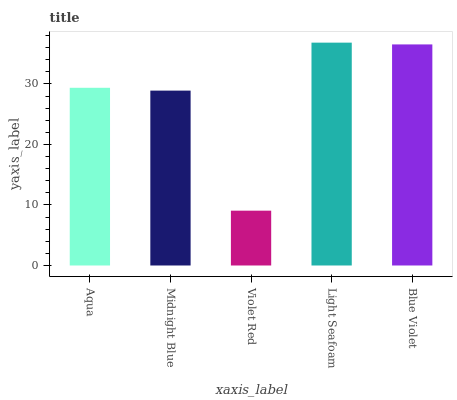Is Violet Red the minimum?
Answer yes or no. Yes. Is Light Seafoam the maximum?
Answer yes or no. Yes. Is Midnight Blue the minimum?
Answer yes or no. No. Is Midnight Blue the maximum?
Answer yes or no. No. Is Aqua greater than Midnight Blue?
Answer yes or no. Yes. Is Midnight Blue less than Aqua?
Answer yes or no. Yes. Is Midnight Blue greater than Aqua?
Answer yes or no. No. Is Aqua less than Midnight Blue?
Answer yes or no. No. Is Aqua the high median?
Answer yes or no. Yes. Is Aqua the low median?
Answer yes or no. Yes. Is Violet Red the high median?
Answer yes or no. No. Is Blue Violet the low median?
Answer yes or no. No. 